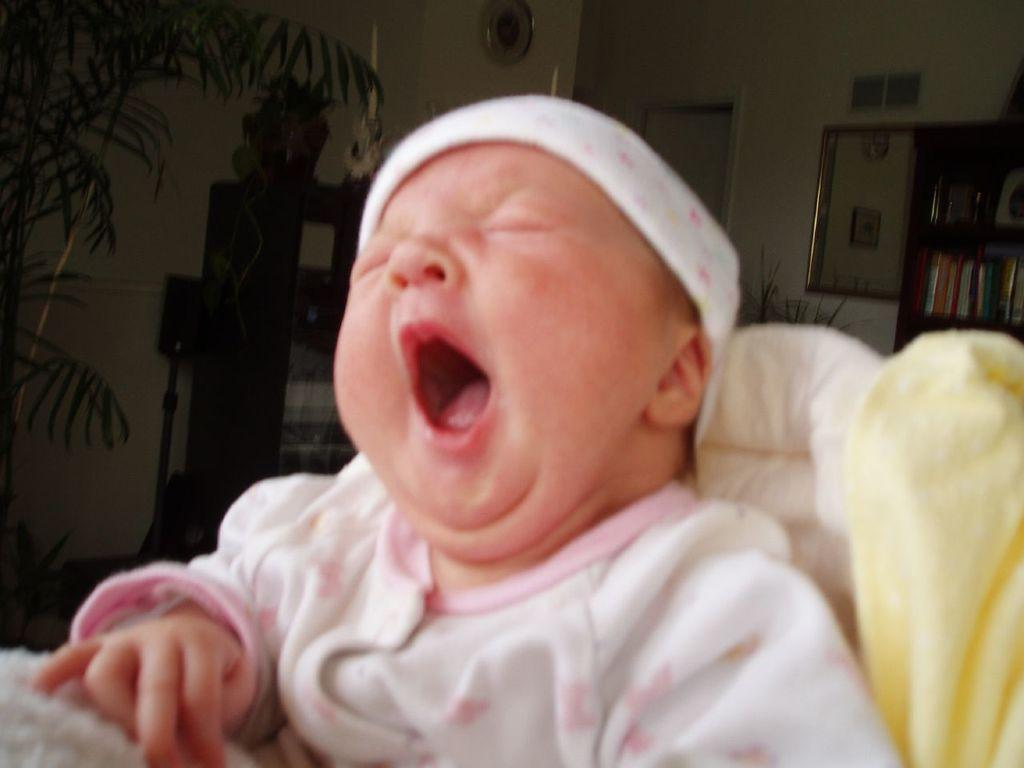What is the main subject of the image? There is a kid in the image. What is the kid doing in the image? The kid is yawning. What can be seen in the background of the image? There is a plant and cupboards in the background of the image. Are there any decorative elements on the wall in the image? Yes, there are frames on the wall in the image. What type of railway can be seen in the image? There is no railway present in the image. What activities might be taking place in the park shown in the image? There is no park present in the image. 